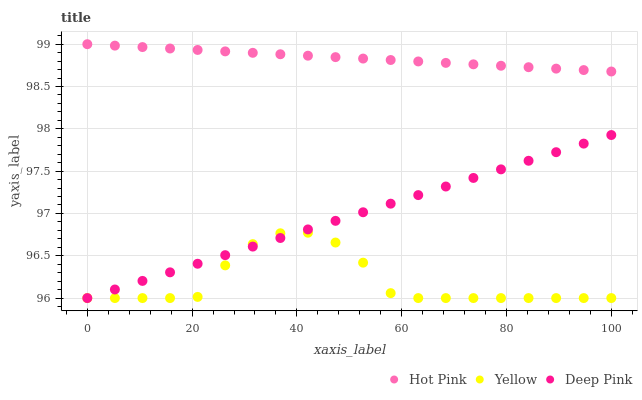Does Yellow have the minimum area under the curve?
Answer yes or no. Yes. Does Hot Pink have the maximum area under the curve?
Answer yes or no. Yes. Does Deep Pink have the minimum area under the curve?
Answer yes or no. No. Does Deep Pink have the maximum area under the curve?
Answer yes or no. No. Is Deep Pink the smoothest?
Answer yes or no. Yes. Is Yellow the roughest?
Answer yes or no. Yes. Is Yellow the smoothest?
Answer yes or no. No. Is Deep Pink the roughest?
Answer yes or no. No. Does Yellow have the lowest value?
Answer yes or no. Yes. Does Hot Pink have the highest value?
Answer yes or no. Yes. Does Deep Pink have the highest value?
Answer yes or no. No. Is Yellow less than Hot Pink?
Answer yes or no. Yes. Is Hot Pink greater than Yellow?
Answer yes or no. Yes. Does Deep Pink intersect Yellow?
Answer yes or no. Yes. Is Deep Pink less than Yellow?
Answer yes or no. No. Is Deep Pink greater than Yellow?
Answer yes or no. No. Does Yellow intersect Hot Pink?
Answer yes or no. No. 